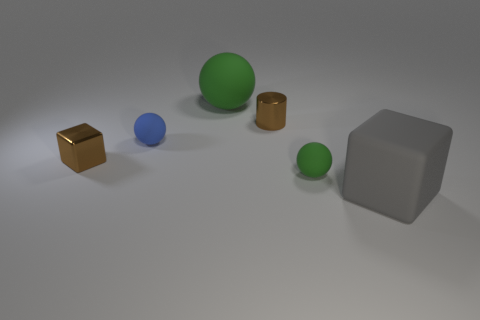There is a large rubber ball; is its color the same as the small matte ball that is right of the blue matte sphere?
Your answer should be very brief. Yes. Are there any big red metallic objects that have the same shape as the small blue rubber thing?
Keep it short and to the point. No. Is the number of shiny objects on the left side of the blue rubber object the same as the number of large green spheres?
Ensure brevity in your answer.  Yes. What shape is the small matte object that is the same color as the large matte sphere?
Ensure brevity in your answer.  Sphere. How many blue cylinders have the same size as the shiny cube?
Keep it short and to the point. 0. There is a large gray thing; how many big green objects are in front of it?
Your answer should be compact. 0. What material is the small brown thing that is right of the tiny sphere behind the metallic block?
Ensure brevity in your answer.  Metal. Is there a big rubber ball of the same color as the tiny shiny block?
Offer a very short reply. No. What size is the gray object that is made of the same material as the large green object?
Keep it short and to the point. Large. Is there anything else that is the same color as the rubber block?
Ensure brevity in your answer.  No. 